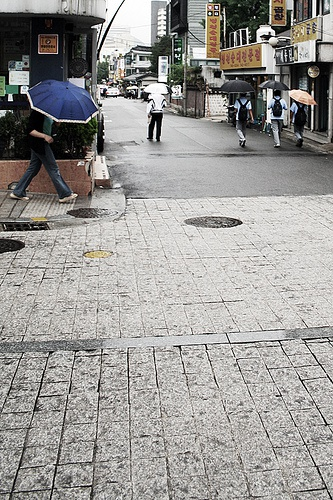Describe the objects in this image and their specific colors. I can see umbrella in lightgray, navy, blue, darkblue, and black tones, people in lightgray, black, gray, and blue tones, people in lightgray, black, gray, and darkgray tones, people in lightgray, black, white, gray, and darkgray tones, and people in lightgray, black, darkgray, and gray tones in this image. 